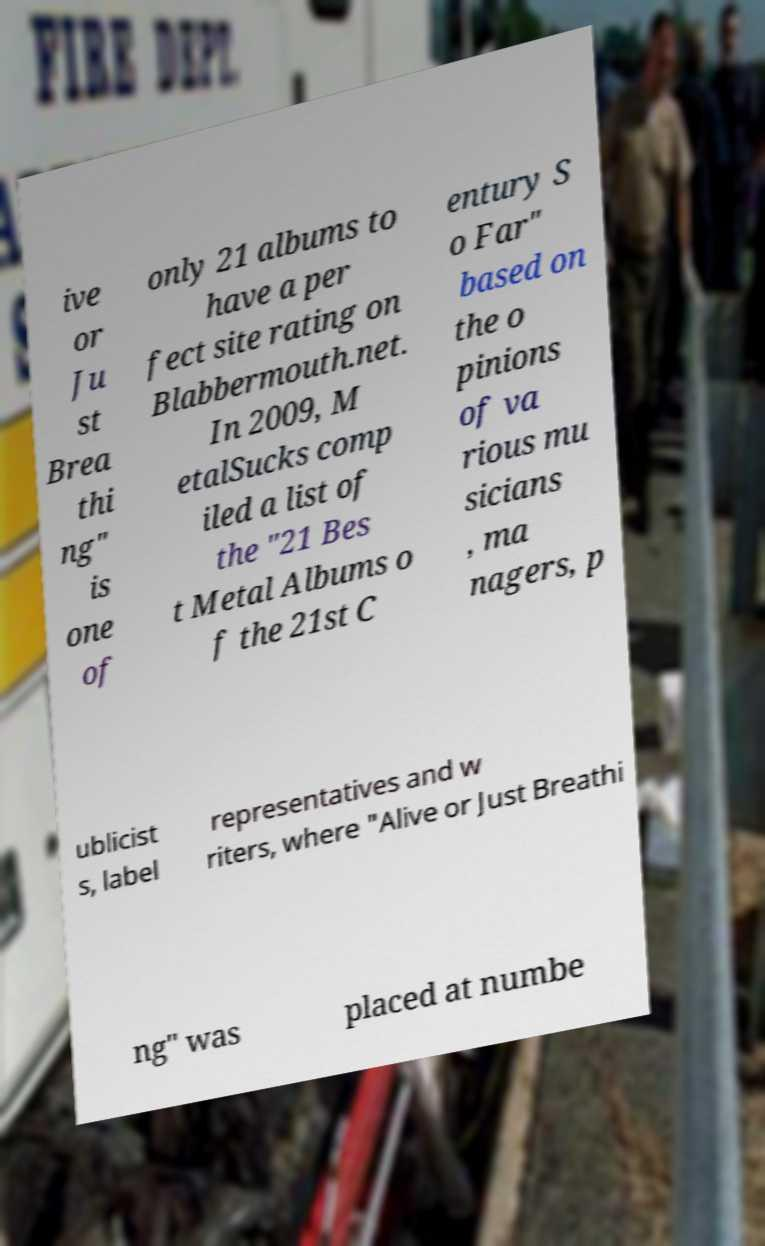For documentation purposes, I need the text within this image transcribed. Could you provide that? ive or Ju st Brea thi ng" is one of only 21 albums to have a per fect site rating on Blabbermouth.net. In 2009, M etalSucks comp iled a list of the "21 Bes t Metal Albums o f the 21st C entury S o Far" based on the o pinions of va rious mu sicians , ma nagers, p ublicist s, label representatives and w riters, where "Alive or Just Breathi ng" was placed at numbe 